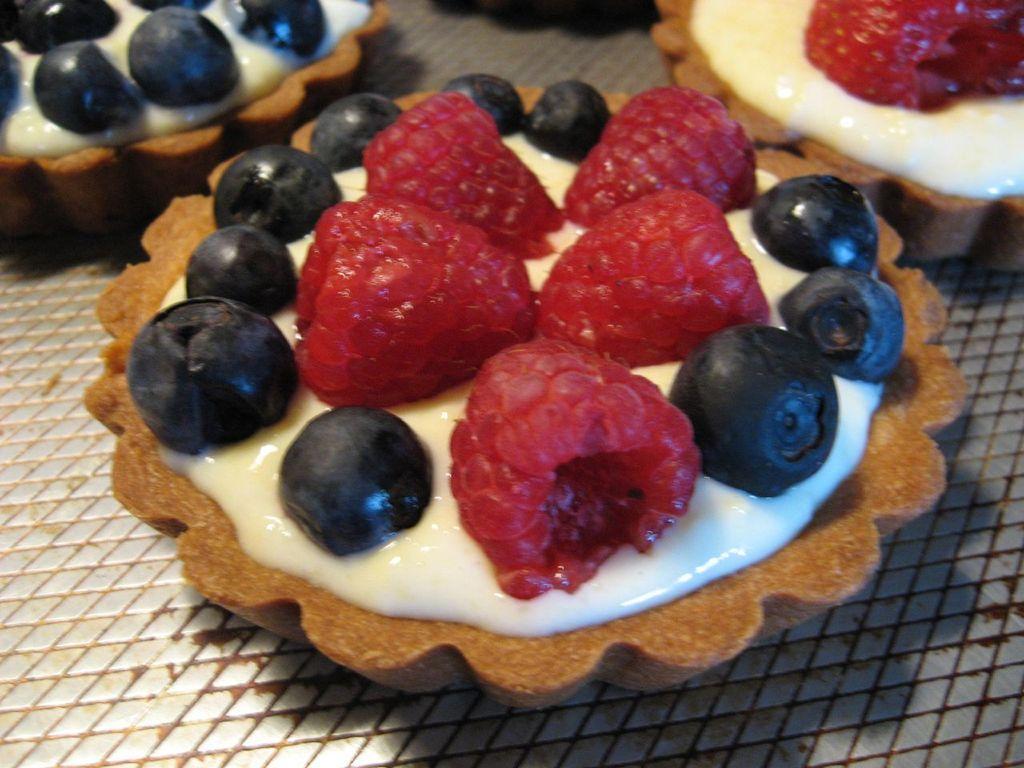Could you give a brief overview of what you see in this image? The picture consists of food items, looking like cookies on a plate. 